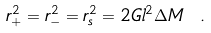Convert formula to latex. <formula><loc_0><loc_0><loc_500><loc_500>r _ { + } ^ { 2 } = r _ { - } ^ { 2 } = r _ { s } ^ { 2 } = 2 G l ^ { 2 } \Delta M \ .</formula> 